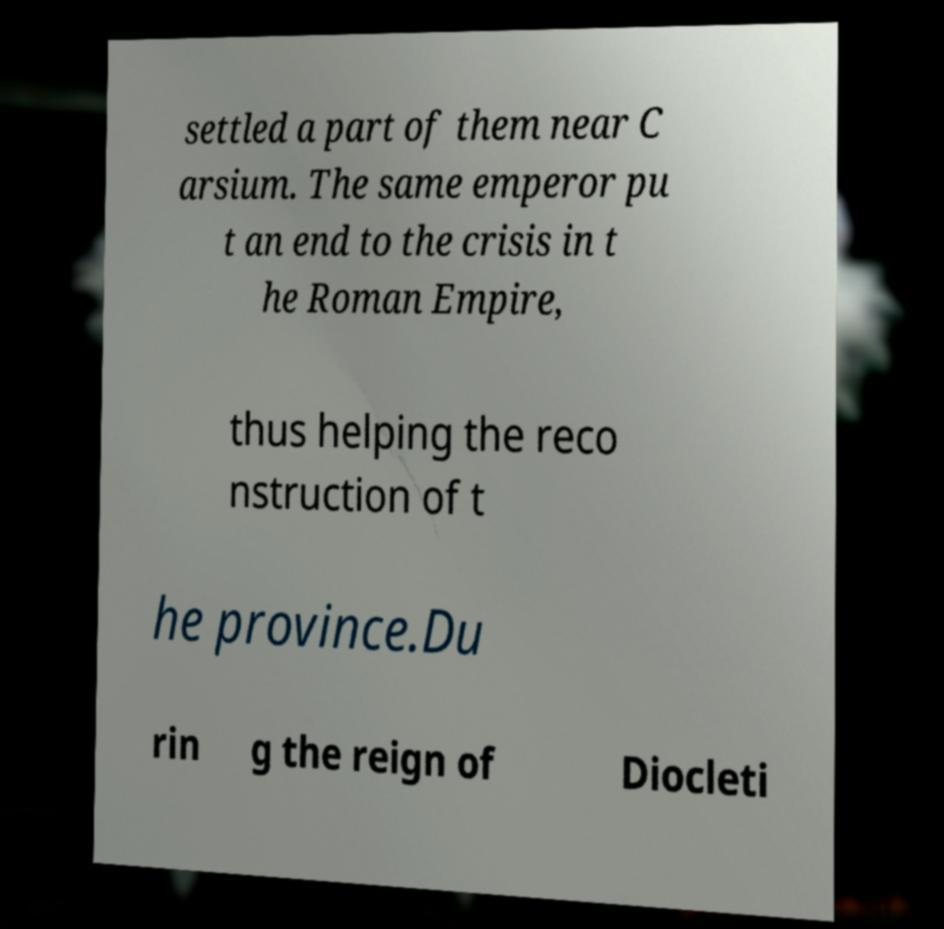Can you read and provide the text displayed in the image?This photo seems to have some interesting text. Can you extract and type it out for me? settled a part of them near C arsium. The same emperor pu t an end to the crisis in t he Roman Empire, thus helping the reco nstruction of t he province.Du rin g the reign of Diocleti 